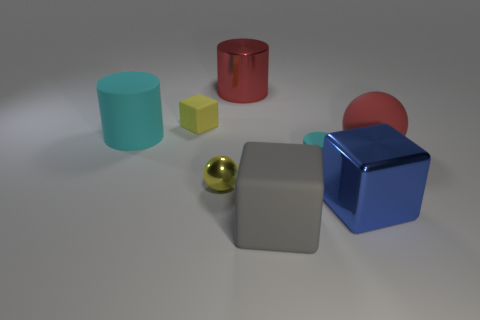Add 2 large shiny balls. How many objects exist? 10 Subtract all red balls. How many cyan cylinders are left? 2 Subtract all rubber cylinders. How many cylinders are left? 1 Subtract all gray blocks. How many blocks are left? 2 Subtract all cubes. How many objects are left? 5 Add 7 small cylinders. How many small cylinders exist? 8 Subtract 1 red spheres. How many objects are left? 7 Subtract all purple balls. Subtract all brown cubes. How many balls are left? 2 Subtract all metal blocks. Subtract all cyan matte objects. How many objects are left? 5 Add 5 large cyan matte cylinders. How many large cyan matte cylinders are left? 6 